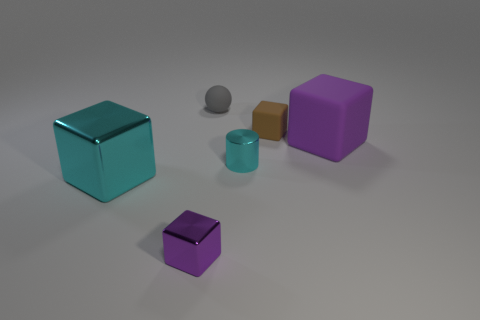What number of blocks are in front of the tiny brown thing?
Ensure brevity in your answer.  3. Is the large thing behind the cyan shiny cylinder made of the same material as the large block left of the metal cylinder?
Your answer should be compact. No. The cyan object behind the big block that is left of the object that is in front of the big cyan metallic cube is what shape?
Your answer should be very brief. Cylinder. What is the shape of the tiny purple object?
Your answer should be very brief. Cube. The cyan object that is the same size as the brown matte thing is what shape?
Your answer should be very brief. Cylinder. How many other objects are the same color as the metallic cylinder?
Your answer should be compact. 1. There is a large thing to the right of the gray sphere; is it the same shape as the tiny metallic thing that is on the left side of the small gray rubber thing?
Give a very brief answer. Yes. What number of things are rubber objects on the left side of the big rubber cube or small things that are behind the tiny purple object?
Provide a succinct answer. 3. How many other objects are there of the same material as the tiny cylinder?
Your answer should be very brief. 2. Is the material of the cyan thing right of the small gray object the same as the tiny brown object?
Make the answer very short. No. 